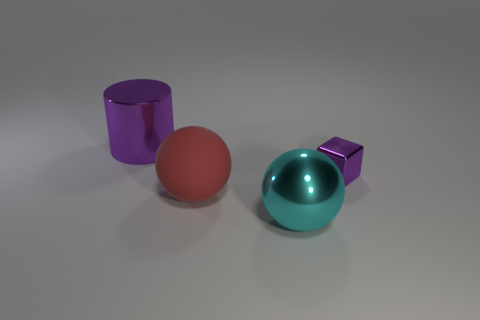Add 1 purple rubber balls. How many objects exist? 5 Subtract all cylinders. How many objects are left? 3 Add 2 tiny cylinders. How many tiny cylinders exist? 2 Subtract 0 cyan cubes. How many objects are left? 4 Subtract all rubber objects. Subtract all gray objects. How many objects are left? 3 Add 2 big shiny things. How many big shiny things are left? 4 